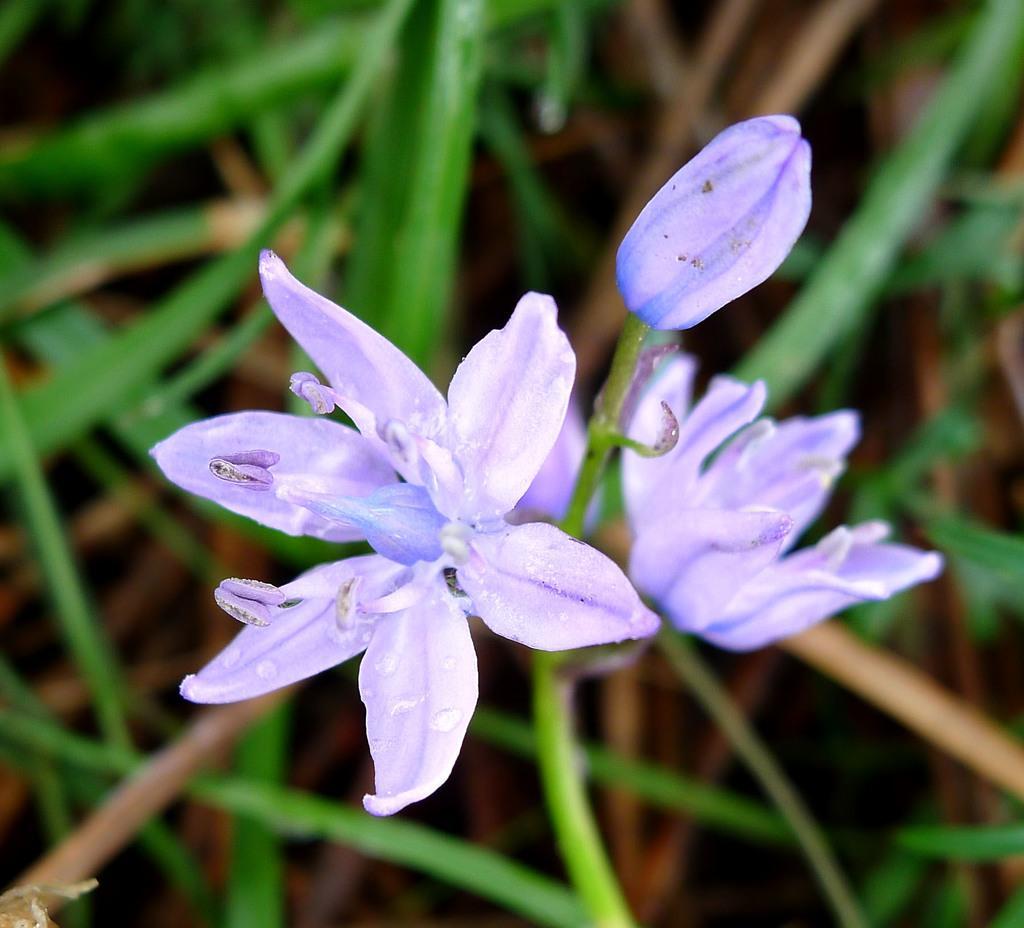Please provide a concise description of this image. In the center of the image we can see flowers are there. In the background of the image leaves are present. 